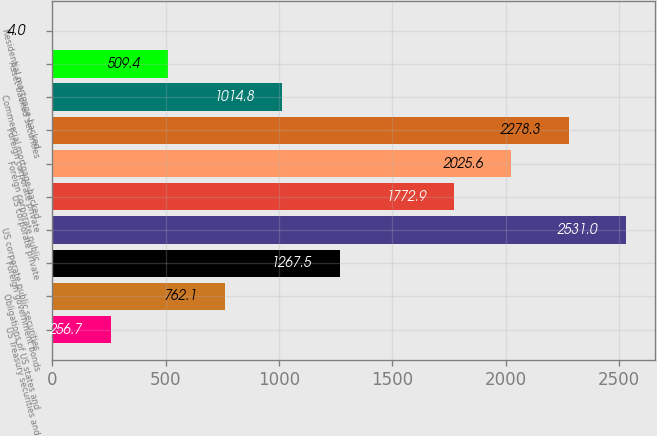Convert chart to OTSL. <chart><loc_0><loc_0><loc_500><loc_500><bar_chart><fcel>US Treasury securities and<fcel>Obligations of US states and<fcel>Foreign government bonds<fcel>US corporate public securities<fcel>US corporate private<fcel>Foreign corporate public<fcel>Foreign corporate private<fcel>Commercial mortgage-backed<fcel>Asset-backed securities<fcel>Residential mortgage-backed<nl><fcel>256.7<fcel>762.1<fcel>1267.5<fcel>2531<fcel>1772.9<fcel>2025.6<fcel>2278.3<fcel>1014.8<fcel>509.4<fcel>4<nl></chart> 